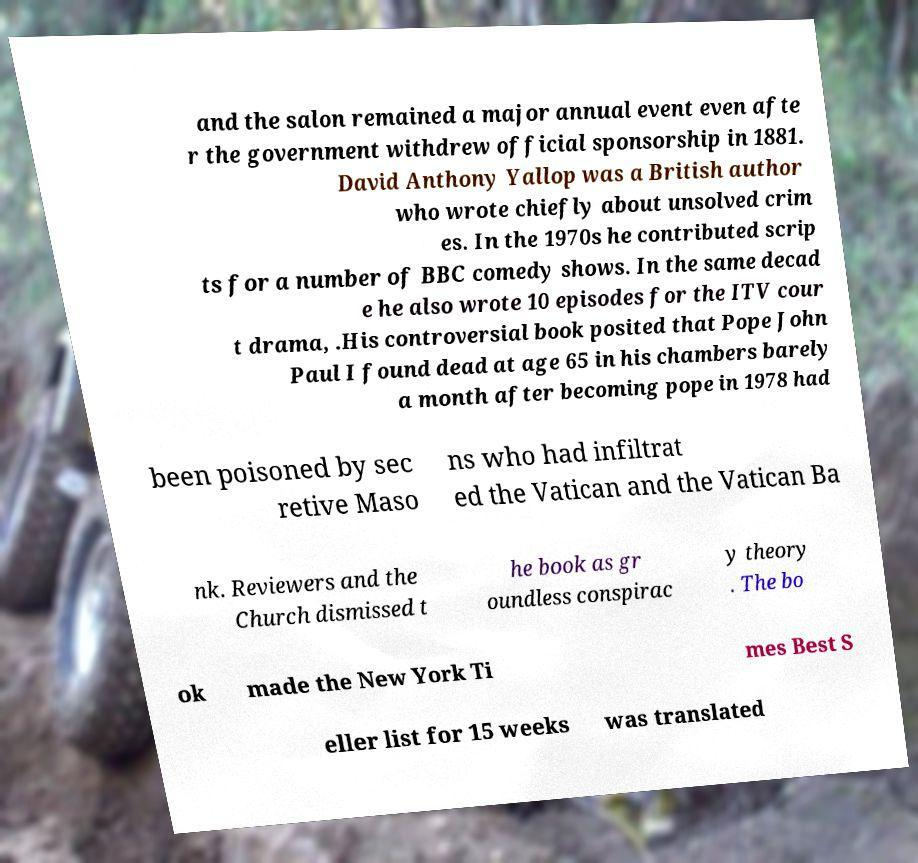Please identify and transcribe the text found in this image. and the salon remained a major annual event even afte r the government withdrew official sponsorship in 1881. David Anthony Yallop was a British author who wrote chiefly about unsolved crim es. In the 1970s he contributed scrip ts for a number of BBC comedy shows. In the same decad e he also wrote 10 episodes for the ITV cour t drama, .His controversial book posited that Pope John Paul I found dead at age 65 in his chambers barely a month after becoming pope in 1978 had been poisoned by sec retive Maso ns who had infiltrat ed the Vatican and the Vatican Ba nk. Reviewers and the Church dismissed t he book as gr oundless conspirac y theory . The bo ok made the New York Ti mes Best S eller list for 15 weeks was translated 